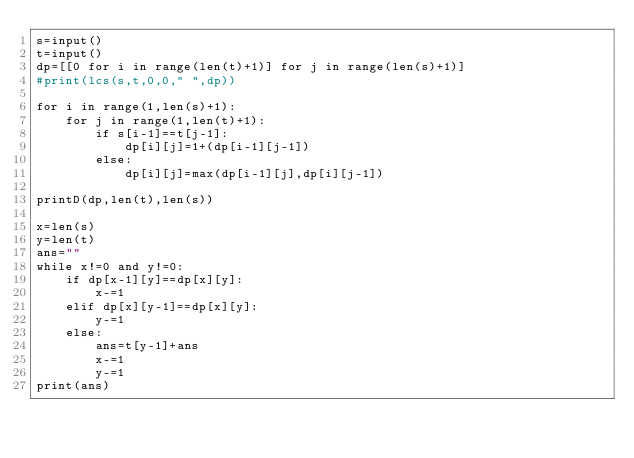Convert code to text. <code><loc_0><loc_0><loc_500><loc_500><_Python_>s=input()
t=input()
dp=[[0 for i in range(len(t)+1)] for j in range(len(s)+1)]
#print(lcs(s,t,0,0," ",dp))

for i in range(1,len(s)+1):
    for j in range(1,len(t)+1):
        if s[i-1]==t[j-1]:
            dp[i][j]=1+(dp[i-1][j-1])
        else:
            dp[i][j]=max(dp[i-1][j],dp[i][j-1])

printD(dp,len(t),len(s))

x=len(s)
y=len(t)
ans=""
while x!=0 and y!=0:
    if dp[x-1][y]==dp[x][y]:
        x-=1
    elif dp[x][y-1]==dp[x][y]:
        y-=1
    else:
        ans=t[y-1]+ans
        x-=1
        y-=1
print(ans)</code> 